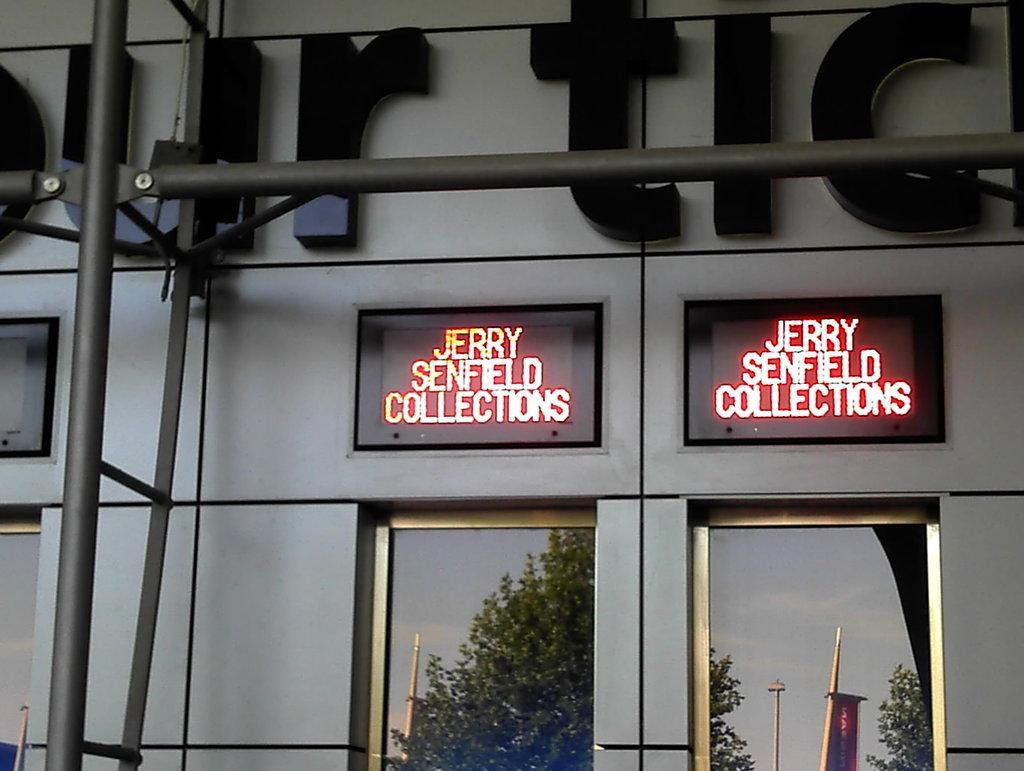Describe this image in one or two sentences. In this picture we can see few metal rods, digital displays, trees and poles, and also we can see a building. 